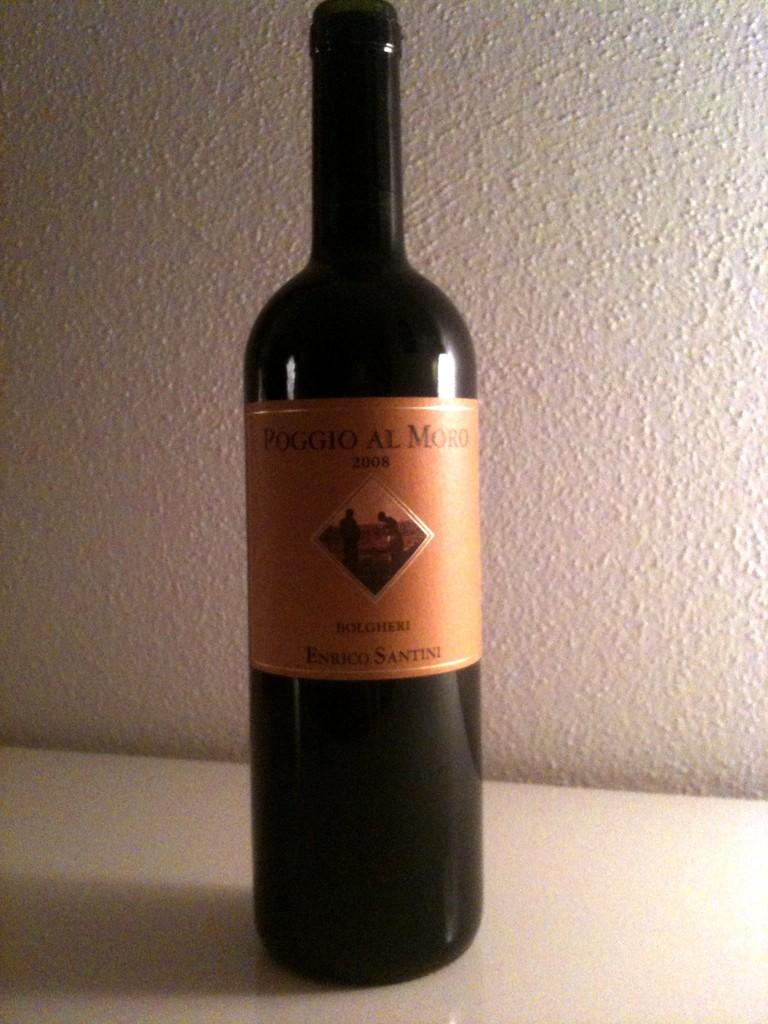Provide a one-sentence caption for the provided image. A bottle of Poggio Al Moro sits on a white countertop. 